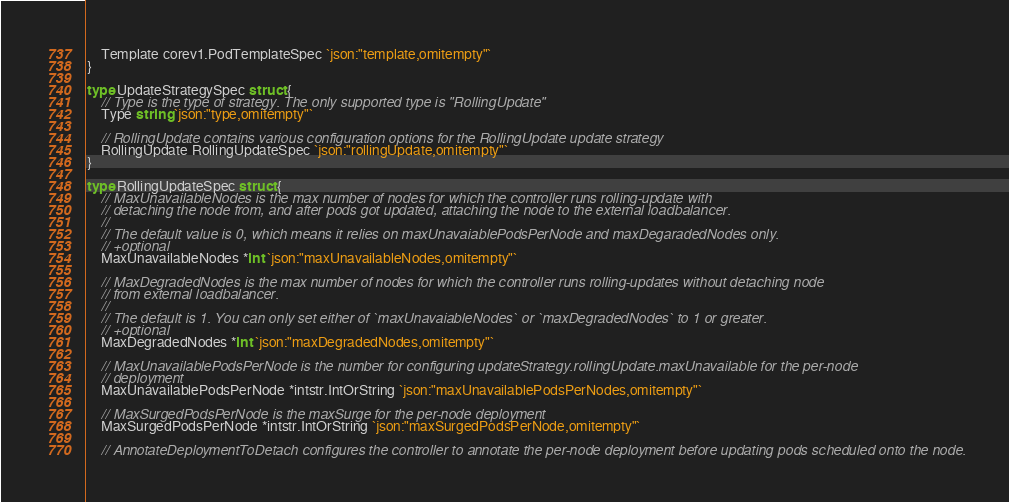Convert code to text. <code><loc_0><loc_0><loc_500><loc_500><_Go_>
	Template corev1.PodTemplateSpec `json:"template,omitempty"`
}

type UpdateStrategySpec struct {
	// Type is the type of strategy. The only supported type is "RollingUpdate"
	Type string `json:"type,omitempty"`

	// RollingUpdate contains various configuration options for the RollingUpdate update strategy
	RollingUpdate RollingUpdateSpec `json:"rollingUpdate,omitempty"`
}

type RollingUpdateSpec struct {
	// MaxUnavailableNodes is the max number of nodes for which the controller runs rolling-update with
	// detaching the node from, and after pods got updated, attaching the node to the external loadbalancer.
	//
	// The default value is 0, which means it relies on maxUnavaiablePodsPerNode and maxDegaradedNodes only.
	// +optional
	MaxUnavailableNodes *int `json:"maxUnavailableNodes,omitempty"`

	// MaxDegradedNodes is the max number of nodes for which the controller runs rolling-updates without detaching node
	// from external loadbalancer.
	//
	// The default is 1. You can only set either of `maxUnavaiableNodes` or `maxDegradedNodes` to 1 or greater.
	// +optional
	MaxDegradedNodes *int `json:"maxDegradedNodes,omitempty"`

	// MaxUnavailablePodsPerNode is the number for configuring updateStrategy.rollingUpdate.maxUnavailable for the per-node
	// deployment
	MaxUnavailablePodsPerNode *intstr.IntOrString `json:"maxUnavailablePodsPerNodes,omitempty"`

	// MaxSurgedPodsPerNode is the maxSurge for the per-node deployment
	MaxSurgedPodsPerNode *intstr.IntOrString `json:"maxSurgedPodsPerNode,omitempty"`

	// AnnotateDeploymentToDetach configures the controller to annotate the per-node deployment before updating pods scheduled onto the node.</code> 